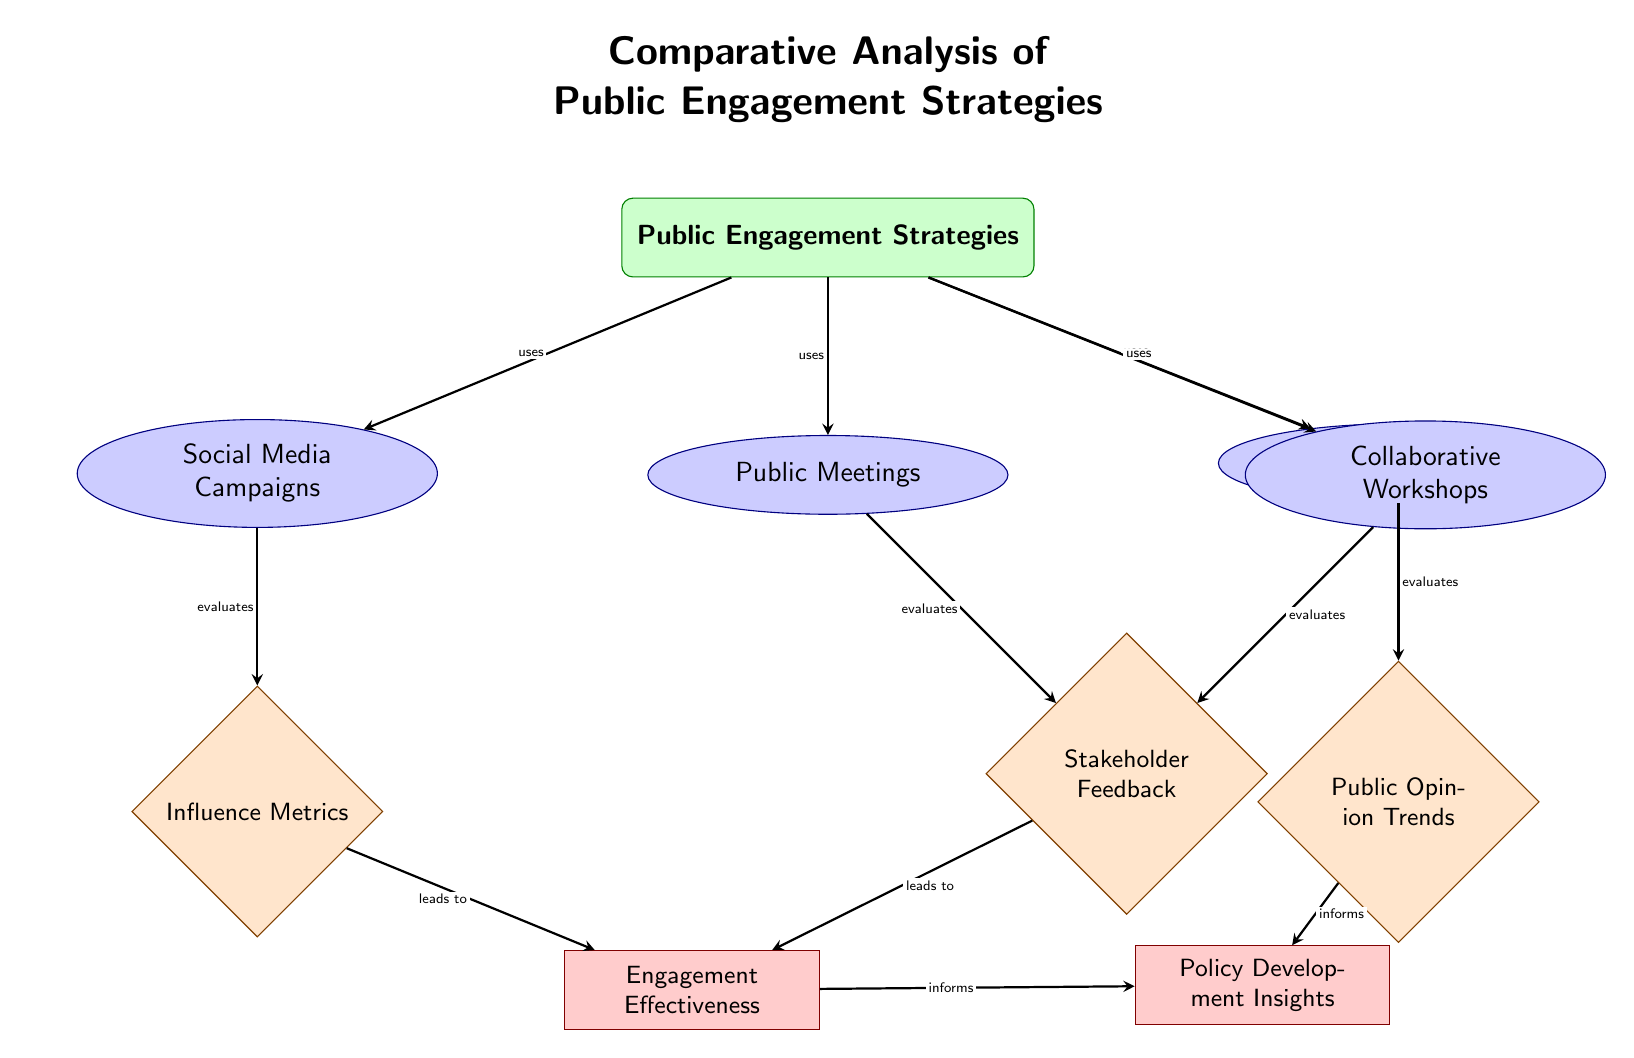What are the four public engagement strategies listed? The diagram shows the four public engagement strategies as "Social Media Campaigns," "Public Meetings," "Surveys and Polls," and "Collaborative Workshops."
Answer: Social Media Campaigns, Public Meetings, Surveys and Polls, Collaborative Workshops How many evaluation metrics are there? There are three evaluation metrics shown in the diagram: "Influence Metrics," "Stakeholder Feedback," and "Public Opinion Trends."
Answer: 3 Which strategy evaluates Stakeholder Feedback? The "Public Meetings" and "Collaborative Workshops" strategies both evaluate Stakeholder Feedback, as indicated by their arrows pointing to the evaluation node labeled "Stakeholder Feedback."
Answer: Public Meetings, Collaborative Workshops What leads to Engagement Effectiveness? Engagement Effectiveness is informed by both "Influence Metrics" and "Stakeholder Feedback" as indicated by the arrows leading into it from both evaluation metrics.
Answer: Influence Metrics, Stakeholder Feedback Which outcomes are informed by Public Opinion Trends? The outcome "Policy Development Insights" is informed by the "Public Opinion Trends" node, as depicted by the arrow leading from Public Opinion to Insights.
Answer: Policy Development Insights What is the relationship between the “Surveys and Polls” strategy and the evaluation metric it uses? The "Surveys and Polls" strategy evaluates "Public Opinion Trends," shown by the direct arrow connecting the "Surveys and Polls" node to the "Public Opinion Trends" evaluation node.
Answer: Evaluates How many edges connect the evaluation nodes to the outcome nodes? There are four edges connecting evaluation nodes to outcome nodes: two to Engagement Effectiveness and two to Policy Development Insights.
Answer: 4 Which public engagement strategy does not directly evaluate an outcome? "Social Media Campaigns" does not directly evaluate an outcome, as it leads only to "Influence Metrics," not to any outcome node.
Answer: Social Media Campaigns Which evaluation informs both outcomes presented in the diagram? The node "Engagement Effectiveness" informs "Policy Development Insights," indicating that both outcomes are reliant on it as part of the overall public engagement strategy system.
Answer: Engagement Effectiveness 